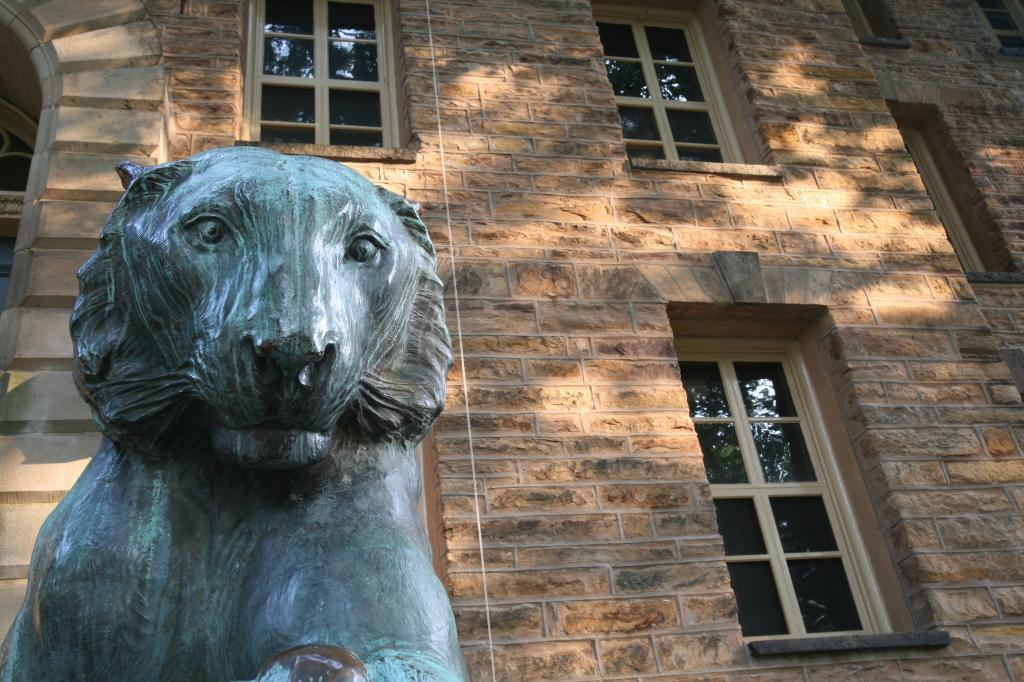What type of object is the main subject of the image? There is a statue of an animal in the image. What can be seen in the background of the image? There is a brown-colored building in the background of the image. Are there any openings visible in the image? Yes, there are windows visible in the image. Can you see any pears falling from the tree near the seashore in the image? There is no tree or seashore present in the image, and therefore no pears can be seen falling. 